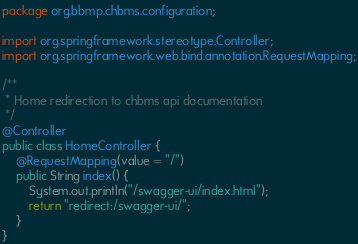<code> <loc_0><loc_0><loc_500><loc_500><_Java_>package org.bbmp.chbms.configuration;

import org.springframework.stereotype.Controller;
import org.springframework.web.bind.annotation.RequestMapping;

/**
 * Home redirection to chbms api documentation
 */
@Controller
public class HomeController {
    @RequestMapping(value = "/")
    public String index() {
        System.out.println("/swagger-ui/index.html");
        return "redirect:/swagger-ui/";
    }
}
</code> 